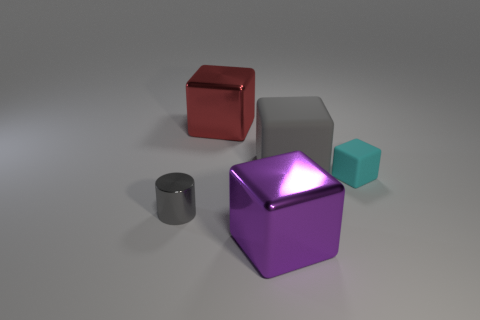There is a big red metal object; how many blocks are to the left of it?
Give a very brief answer. 0. What is the material of the small cube?
Give a very brief answer. Rubber. The big metallic object in front of the small cyan rubber thing behind the large cube that is in front of the gray cylinder is what color?
Your answer should be compact. Purple. What number of gray rubber cubes are the same size as the gray rubber thing?
Ensure brevity in your answer.  0. The metal thing that is on the right side of the red object is what color?
Offer a very short reply. Purple. What number of other objects are there of the same size as the gray metal thing?
Make the answer very short. 1. What is the size of the object that is both in front of the big gray thing and on the right side of the purple thing?
Provide a succinct answer. Small. Does the tiny cylinder have the same color as the big matte block behind the small gray cylinder?
Make the answer very short. Yes. Are there any other matte objects that have the same shape as the large gray matte object?
Your response must be concise. Yes. How many objects are either big purple objects or large metallic objects in front of the small gray cylinder?
Your answer should be very brief. 1. 